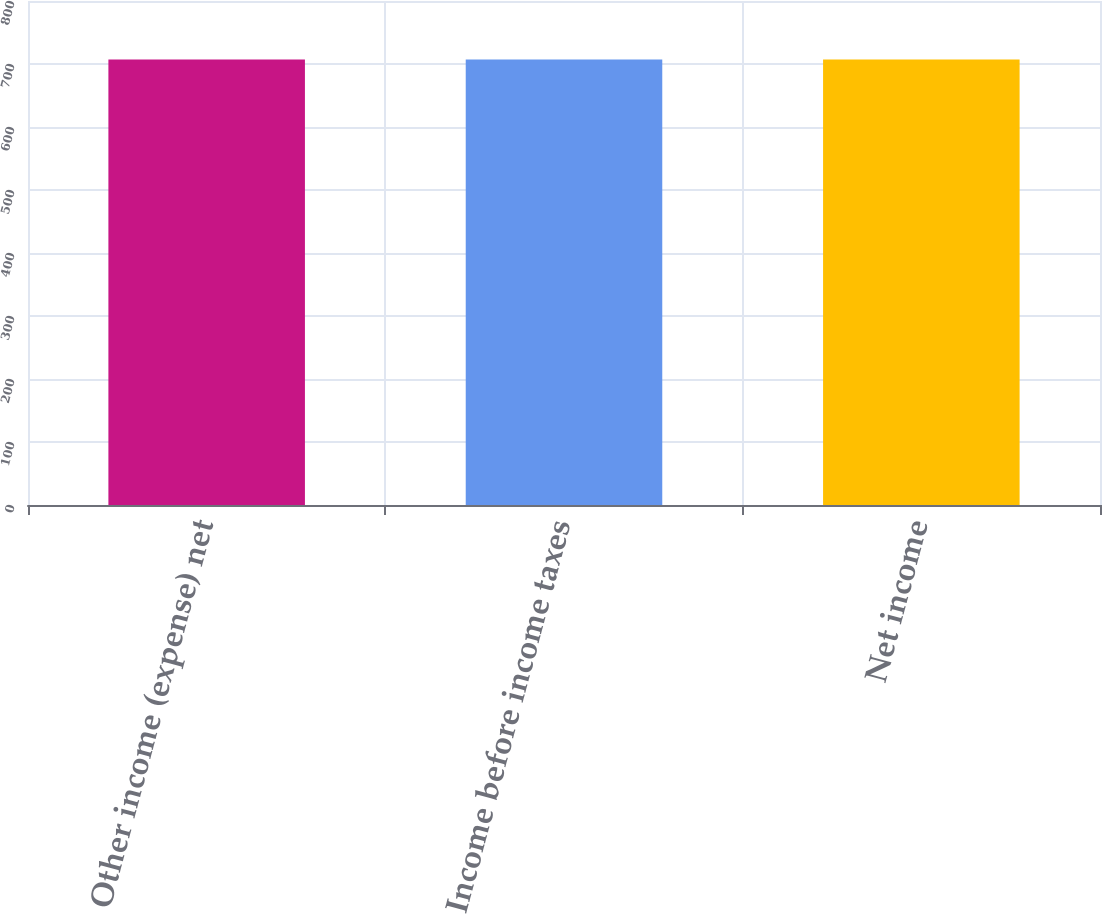Convert chart to OTSL. <chart><loc_0><loc_0><loc_500><loc_500><bar_chart><fcel>Other income (expense) net<fcel>Income before income taxes<fcel>Net income<nl><fcel>707<fcel>707.1<fcel>707.2<nl></chart> 